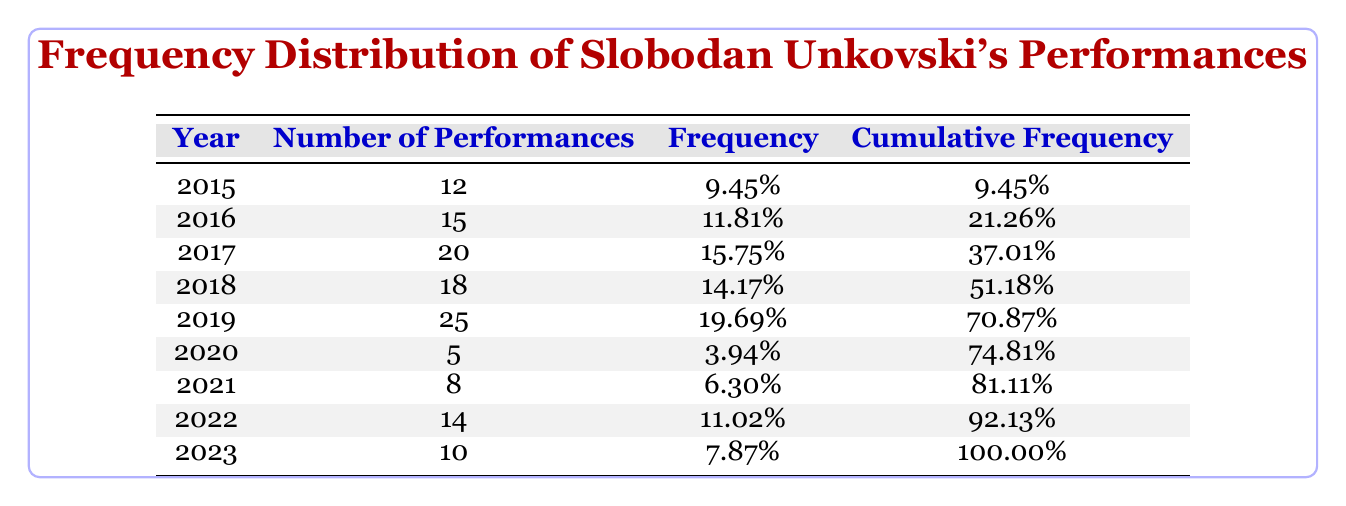What year had the highest number of performances? By looking at the "Number of Performances" column, it's clear that 2019 has the highest value at 25 performances.
Answer: 2019 How many performances were there in 2020? The table shows that there were 5 performances in 2020.
Answer: 5 What is the cumulative frequency of performances in 2018? The cumulative frequency up to 2018 is 51.18%, which adds the individual frequencies of the years leading up to and including 2018.
Answer: 51.18% What is the average number of performances from 2015 to 2023? To find the average, we sum the number of performances: (12 + 15 + 20 + 18 + 25 + 5 + 8 + 14 + 10) = 127. There are 9 years, so the average is 127/9 ≈ 14.11.
Answer: 14.11 Did Slobodan Unkovski's performances decrease in 2021 compared to 2020? Comparing the numbers, 2020 had 5 performances and 2021 had 8 performances, indicating that performances increased from 2020 to 2021.
Answer: No What percentage of total performances was given in 2017? First, we find the total performances: 127. Then we calculate the percentage for 2017 (20): (20/127) * 100 ≈ 15.75%.
Answer: 15.75% Which two consecutive years had the lowest number of performances? The years 2020 (5) and 2021 (8) are consecutive years with the lowest performances, as both numbers are below all others in the table.
Answer: 2020 and 2021 What was the change in the number of performances from 2019 to 2020? From 2019 (25 performances) to 2020 (5 performances), there was a decrease of 20 performances, which is a significant drop.
Answer: Decrease of 20 performances Was the number of performances in 2023 higher than that in 2021? The performances in 2023 were 10 and in 2021 were 8. Since 10 is greater than 8, the number of performances in 2023 was higher.
Answer: Yes 